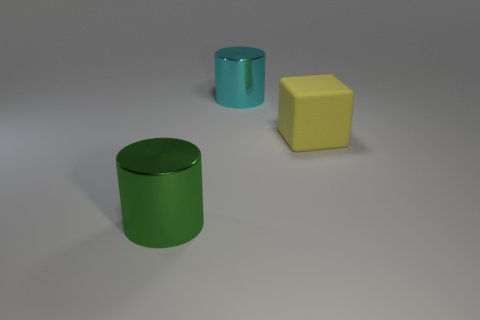What number of cyan cylinders have the same size as the yellow rubber block? There is one cyan cylinder that has the same size as the yellow rubber block, which is aesthetically pleasing due to the balance in size and the contrast in colors. 